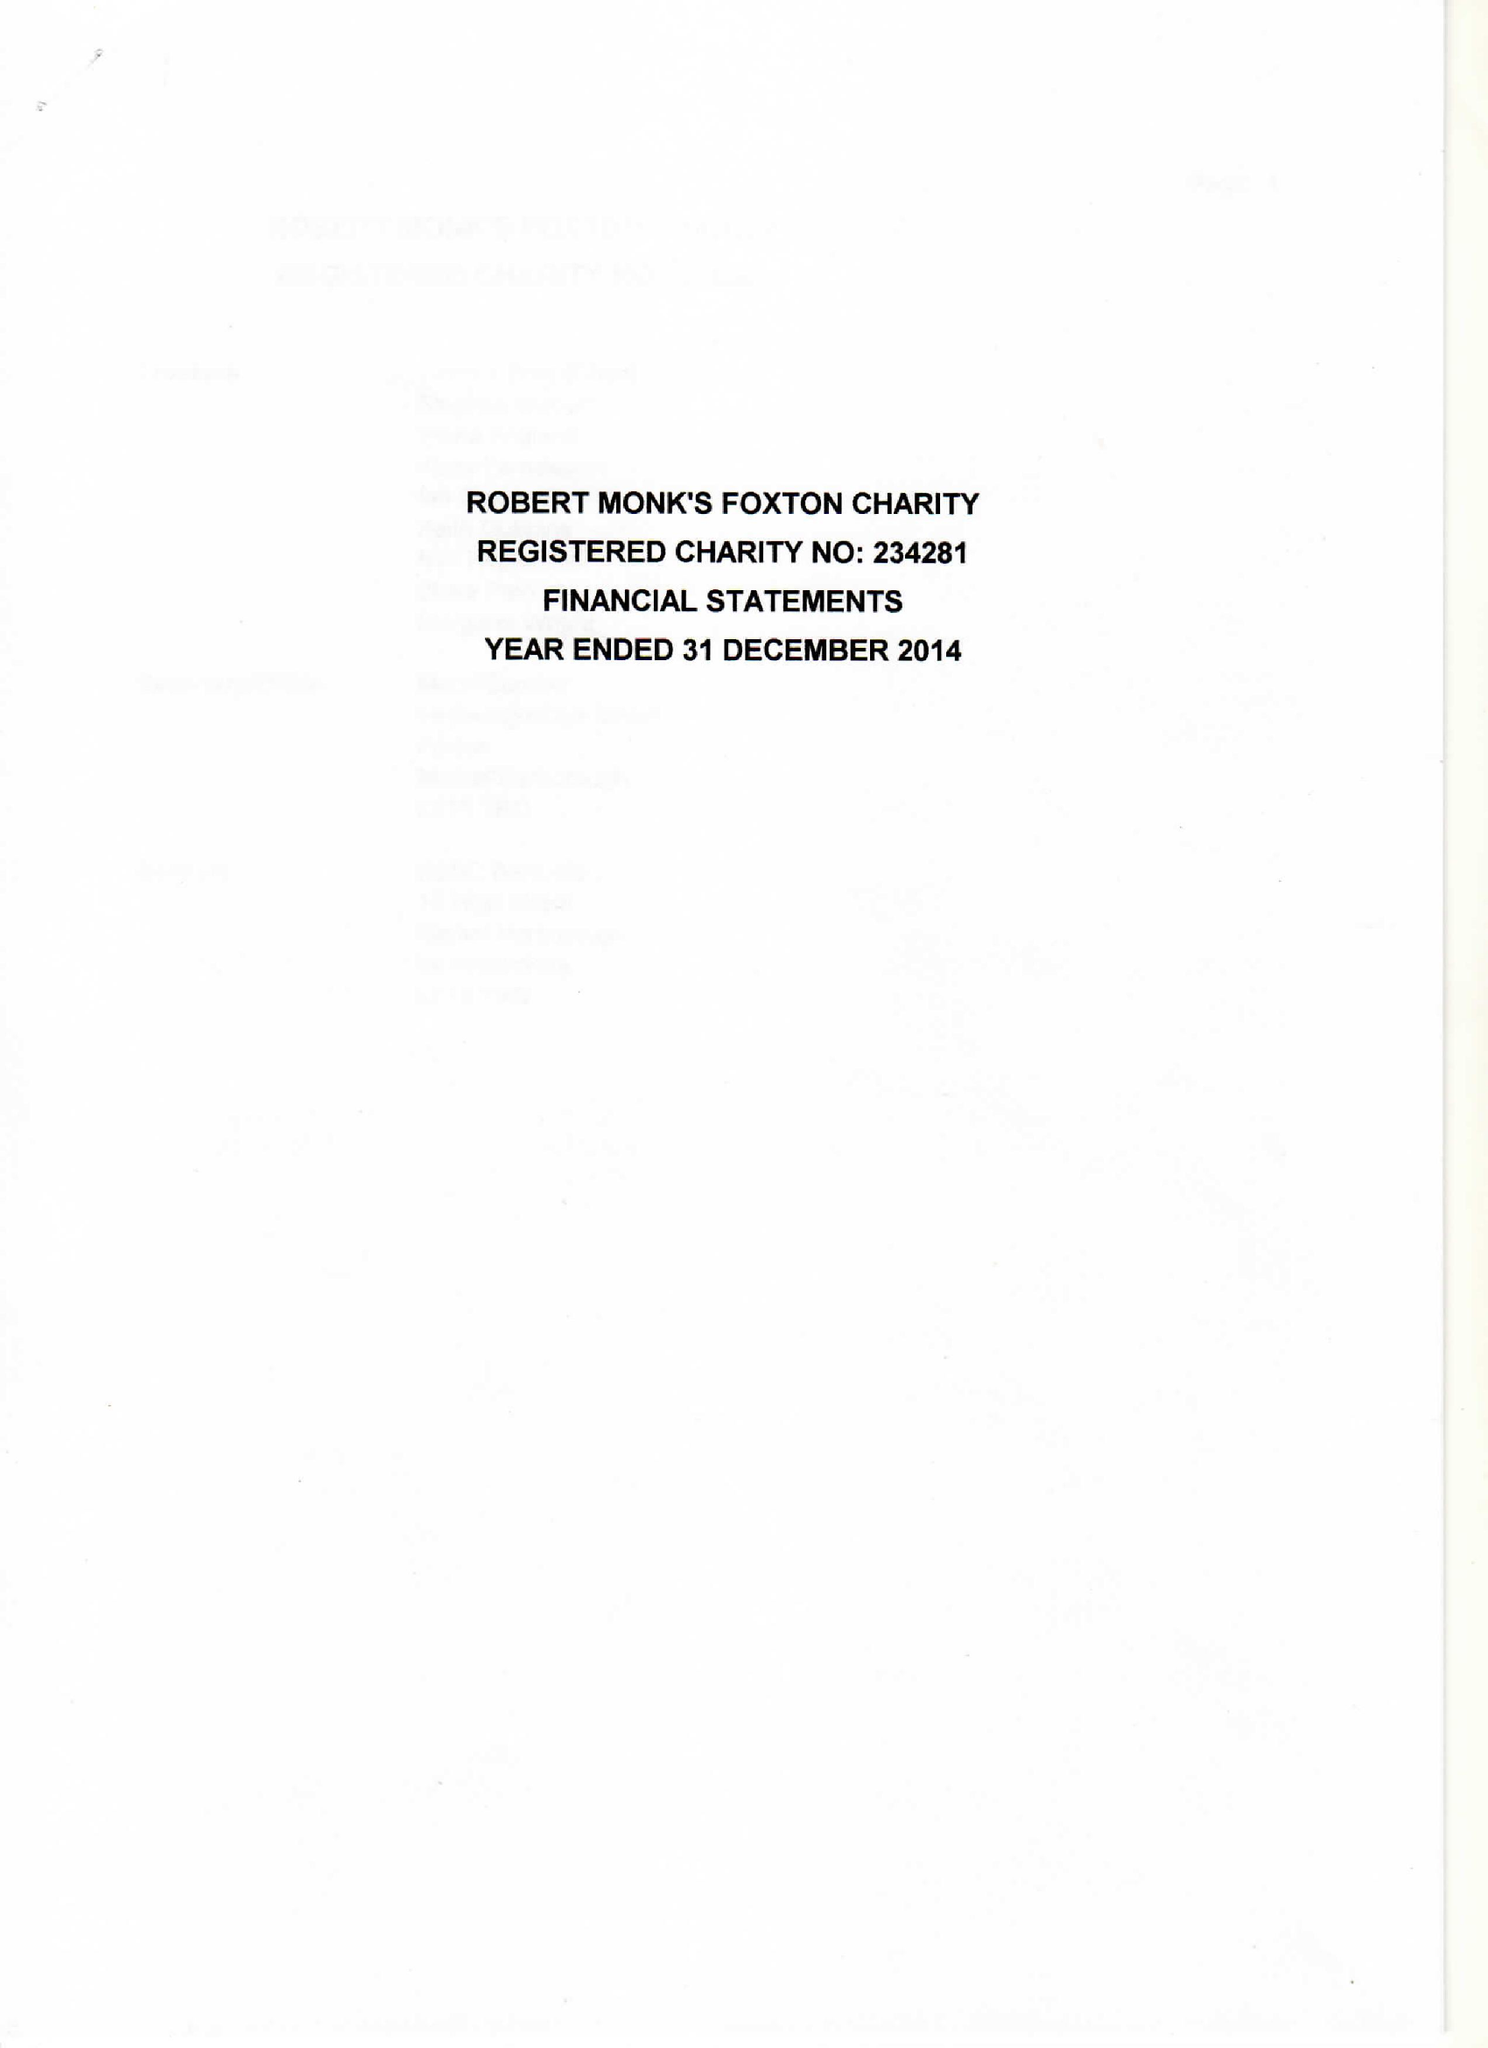What is the value for the report_date?
Answer the question using a single word or phrase. 2014-12-31 